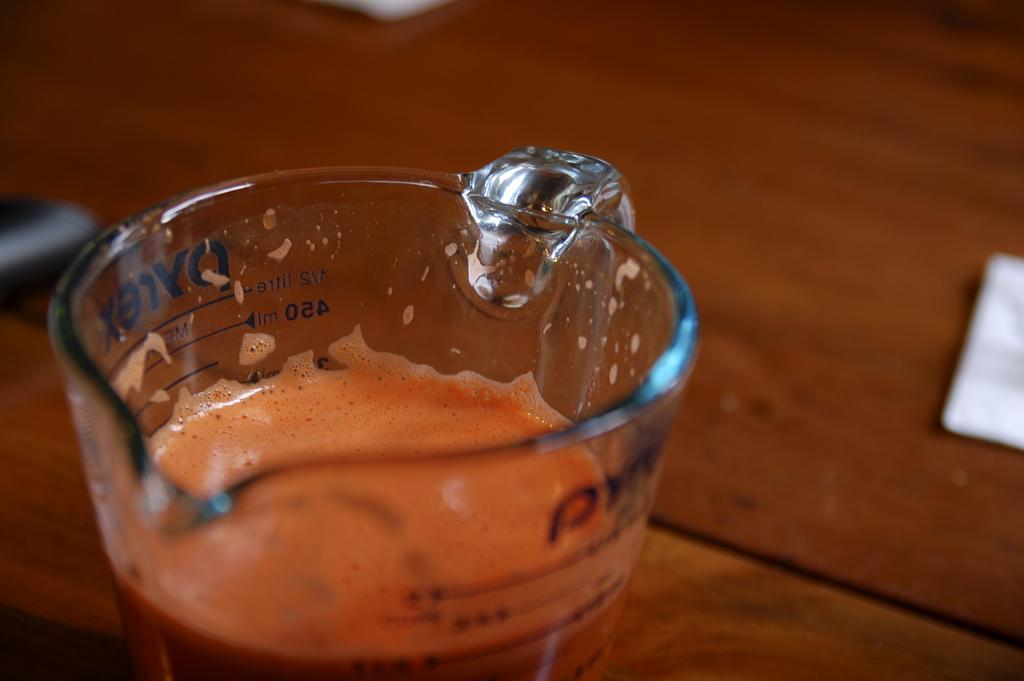What is inside the jar that is visible in the image? The jar contains juice. What type of surface is the jar placed on in the image? The jar is placed on a table in the image. What else can be seen on the table in the image? There are objects on the table in the image. What type of bedroom furniture is visible in the image? There is no bedroom furniture present in the image; it features a jar of juice on a table. How does the coach interact with the objects on the table in the image? There is no coach present in the image; it only features a jar of juice on a table with other objects. 